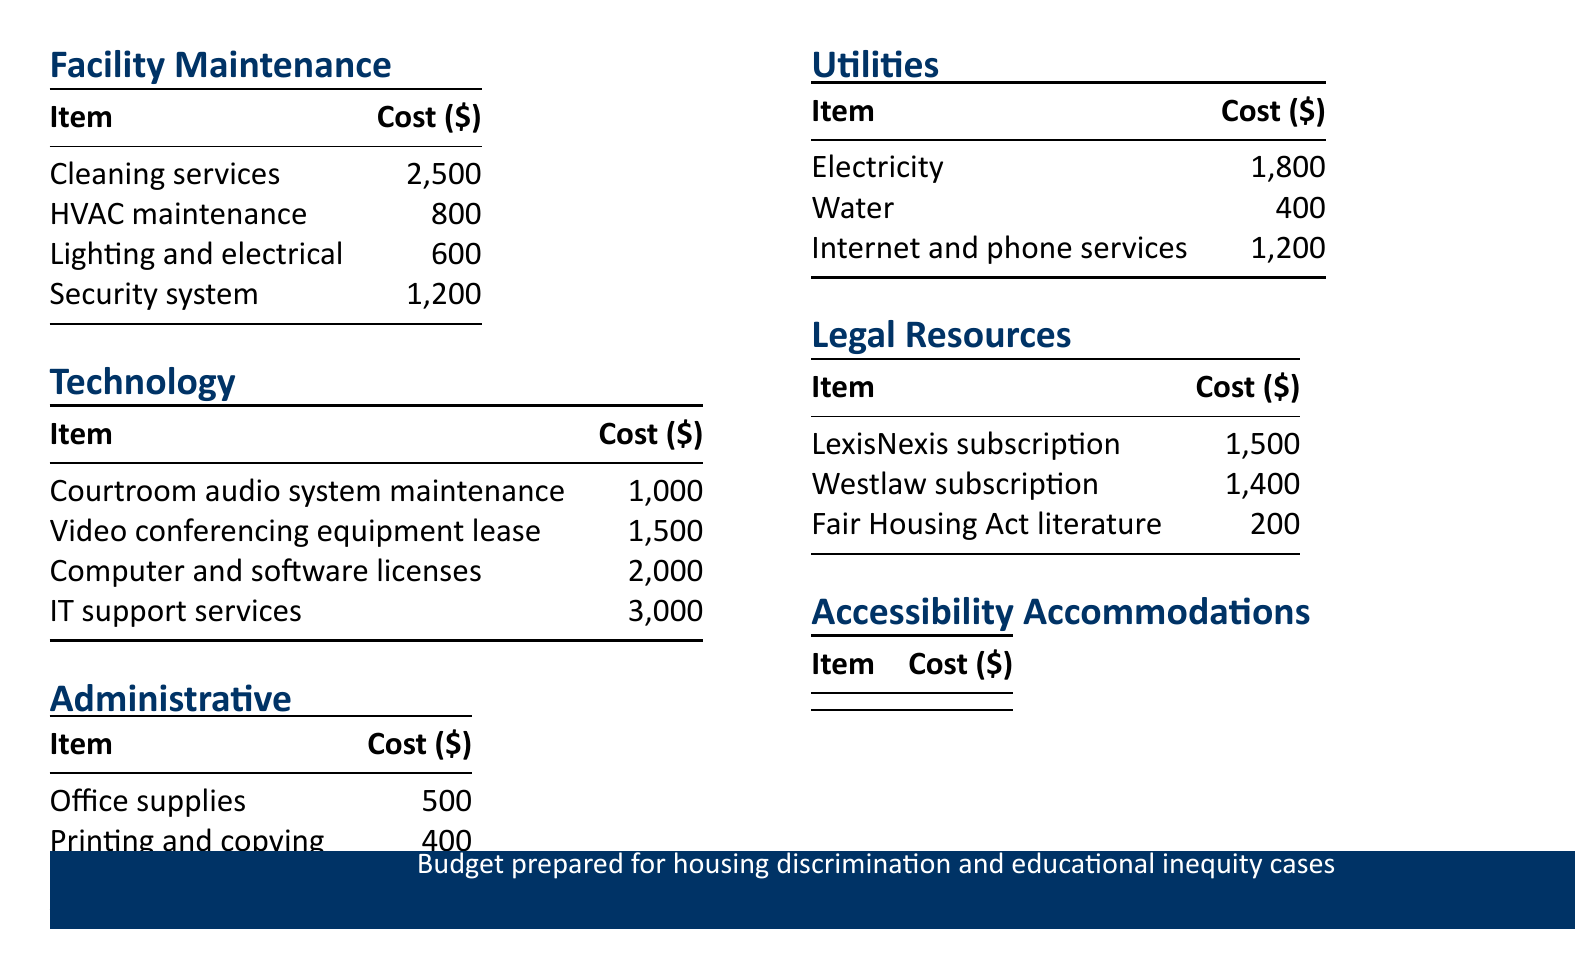What is the total cost for Facility Maintenance? The total cost is the sum of all items listed under Facility Maintenance, which is $2,500 + $800 + $600 + $1,200 = $5,100.
Answer: $5,100 How much does IT support services cost? This cost is specifically listed in the Technology category.
Answer: $3,000 What item costs $300 in Accessibility Accommodations? This is the specific cost associated with Braille document production.
Answer: Braille document production Which subscription has a higher cost, LexisNexis or Westlaw? A comparison between the costs of LexisNexis subscription and Westlaw subscription shows LexisNexis at $1,500 and Westlaw at $1,400.
Answer: LexisNexis What is the total budget allocated for Utilities? The total budget for Utilities is $1,800 + $400 + $1,200 = $3,400.
Answer: $3,400 How many categories are listed in the operational budget? The budget includes six distinct categories outlined in the document.
Answer: Six What is the total cost of Legal Resources? This total is calculated by adding the costs of LexisNexis subscription, Westlaw subscription, and Fair Housing Act literature, which equals $1,500 + $1,400 + $200 = $3,100.
Answer: $3,100 What is the cost for the video conferencing equipment lease? This specific cost is mentioned in the Technology category.
Answer: $1,500 